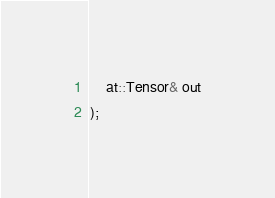Convert code to text. <code><loc_0><loc_0><loc_500><loc_500><_C_>    at::Tensor& out
);</code> 